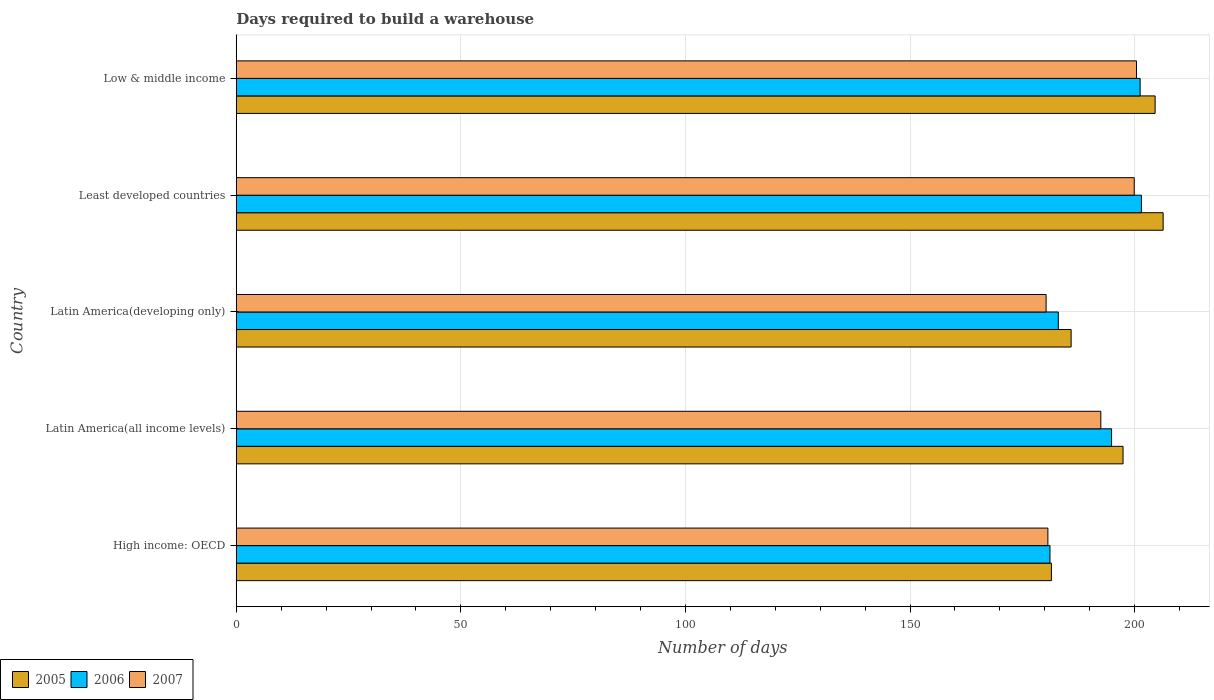How many groups of bars are there?
Offer a very short reply. 5. Are the number of bars per tick equal to the number of legend labels?
Ensure brevity in your answer.  Yes. Are the number of bars on each tick of the Y-axis equal?
Keep it short and to the point. Yes. What is the label of the 2nd group of bars from the top?
Provide a succinct answer. Least developed countries. What is the days required to build a warehouse in in 2007 in Latin America(developing only)?
Your answer should be very brief. 180.29. Across all countries, what is the maximum days required to build a warehouse in in 2007?
Provide a short and direct response. 200.41. Across all countries, what is the minimum days required to build a warehouse in in 2006?
Provide a short and direct response. 181.15. In which country was the days required to build a warehouse in in 2005 maximum?
Provide a short and direct response. Least developed countries. In which country was the days required to build a warehouse in in 2005 minimum?
Give a very brief answer. High income: OECD. What is the total days required to build a warehouse in in 2006 in the graph?
Provide a short and direct response. 961.73. What is the difference between the days required to build a warehouse in in 2006 in Latin America(developing only) and that in Least developed countries?
Provide a short and direct response. -18.5. What is the difference between the days required to build a warehouse in in 2007 in Latin America(developing only) and the days required to build a warehouse in in 2006 in Low & middle income?
Your answer should be very brief. -20.93. What is the average days required to build a warehouse in in 2007 per country?
Your response must be concise. 190.75. What is the difference between the days required to build a warehouse in in 2005 and days required to build a warehouse in in 2006 in Latin America(all income levels)?
Make the answer very short. 2.55. In how many countries, is the days required to build a warehouse in in 2007 greater than 170 days?
Offer a very short reply. 5. What is the ratio of the days required to build a warehouse in in 2005 in Latin America(all income levels) to that in Least developed countries?
Your answer should be compact. 0.96. Is the days required to build a warehouse in in 2006 in Latin America(all income levels) less than that in Latin America(developing only)?
Provide a succinct answer. No. Is the difference between the days required to build a warehouse in in 2005 in Latin America(all income levels) and Latin America(developing only) greater than the difference between the days required to build a warehouse in in 2006 in Latin America(all income levels) and Latin America(developing only)?
Provide a succinct answer. No. What is the difference between the highest and the second highest days required to build a warehouse in in 2006?
Your answer should be compact. 0.28. What is the difference between the highest and the lowest days required to build a warehouse in in 2007?
Ensure brevity in your answer.  20.12. In how many countries, is the days required to build a warehouse in in 2005 greater than the average days required to build a warehouse in in 2005 taken over all countries?
Provide a succinct answer. 3. What does the 3rd bar from the top in Latin America(developing only) represents?
Give a very brief answer. 2005. Is it the case that in every country, the sum of the days required to build a warehouse in in 2006 and days required to build a warehouse in in 2005 is greater than the days required to build a warehouse in in 2007?
Ensure brevity in your answer.  Yes. Are all the bars in the graph horizontal?
Your answer should be compact. Yes. Are the values on the major ticks of X-axis written in scientific E-notation?
Provide a short and direct response. No. What is the title of the graph?
Provide a short and direct response. Days required to build a warehouse. What is the label or title of the X-axis?
Your answer should be compact. Number of days. What is the label or title of the Y-axis?
Your answer should be very brief. Country. What is the Number of days of 2005 in High income: OECD?
Give a very brief answer. 181.47. What is the Number of days in 2006 in High income: OECD?
Ensure brevity in your answer.  181.15. What is the Number of days in 2007 in High income: OECD?
Offer a very short reply. 180.68. What is the Number of days in 2005 in Latin America(all income levels)?
Offer a terse response. 197.41. What is the Number of days of 2006 in Latin America(all income levels)?
Your response must be concise. 194.86. What is the Number of days of 2007 in Latin America(all income levels)?
Make the answer very short. 192.47. What is the Number of days in 2005 in Latin America(developing only)?
Your response must be concise. 185.86. What is the Number of days of 2006 in Latin America(developing only)?
Give a very brief answer. 183. What is the Number of days of 2007 in Latin America(developing only)?
Provide a short and direct response. 180.29. What is the Number of days in 2005 in Least developed countries?
Your response must be concise. 206.34. What is the Number of days of 2006 in Least developed countries?
Offer a terse response. 201.5. What is the Number of days of 2007 in Least developed countries?
Give a very brief answer. 199.9. What is the Number of days of 2005 in Low & middle income?
Your response must be concise. 204.56. What is the Number of days in 2006 in Low & middle income?
Offer a very short reply. 201.22. What is the Number of days of 2007 in Low & middle income?
Provide a succinct answer. 200.41. Across all countries, what is the maximum Number of days in 2005?
Offer a terse response. 206.34. Across all countries, what is the maximum Number of days of 2006?
Your response must be concise. 201.5. Across all countries, what is the maximum Number of days in 2007?
Give a very brief answer. 200.41. Across all countries, what is the minimum Number of days in 2005?
Ensure brevity in your answer.  181.47. Across all countries, what is the minimum Number of days in 2006?
Keep it short and to the point. 181.15. Across all countries, what is the minimum Number of days in 2007?
Provide a short and direct response. 180.29. What is the total Number of days in 2005 in the graph?
Give a very brief answer. 975.63. What is the total Number of days of 2006 in the graph?
Make the answer very short. 961.73. What is the total Number of days in 2007 in the graph?
Give a very brief answer. 953.75. What is the difference between the Number of days of 2005 in High income: OECD and that in Latin America(all income levels)?
Give a very brief answer. -15.95. What is the difference between the Number of days of 2006 in High income: OECD and that in Latin America(all income levels)?
Make the answer very short. -13.71. What is the difference between the Number of days of 2007 in High income: OECD and that in Latin America(all income levels)?
Provide a short and direct response. -11.78. What is the difference between the Number of days in 2005 in High income: OECD and that in Latin America(developing only)?
Offer a very short reply. -4.39. What is the difference between the Number of days in 2006 in High income: OECD and that in Latin America(developing only)?
Make the answer very short. -1.85. What is the difference between the Number of days of 2007 in High income: OECD and that in Latin America(developing only)?
Offer a very short reply. 0.4. What is the difference between the Number of days in 2005 in High income: OECD and that in Least developed countries?
Make the answer very short. -24.88. What is the difference between the Number of days in 2006 in High income: OECD and that in Least developed countries?
Your answer should be compact. -20.35. What is the difference between the Number of days in 2007 in High income: OECD and that in Least developed countries?
Provide a short and direct response. -19.22. What is the difference between the Number of days in 2005 in High income: OECD and that in Low & middle income?
Offer a very short reply. -23.09. What is the difference between the Number of days of 2006 in High income: OECD and that in Low & middle income?
Provide a succinct answer. -20.07. What is the difference between the Number of days of 2007 in High income: OECD and that in Low & middle income?
Offer a terse response. -19.73. What is the difference between the Number of days of 2005 in Latin America(all income levels) and that in Latin America(developing only)?
Provide a short and direct response. 11.56. What is the difference between the Number of days of 2006 in Latin America(all income levels) and that in Latin America(developing only)?
Give a very brief answer. 11.86. What is the difference between the Number of days in 2007 in Latin America(all income levels) and that in Latin America(developing only)?
Give a very brief answer. 12.18. What is the difference between the Number of days in 2005 in Latin America(all income levels) and that in Least developed countries?
Offer a terse response. -8.93. What is the difference between the Number of days of 2006 in Latin America(all income levels) and that in Least developed countries?
Provide a short and direct response. -6.64. What is the difference between the Number of days of 2007 in Latin America(all income levels) and that in Least developed countries?
Provide a succinct answer. -7.44. What is the difference between the Number of days in 2005 in Latin America(all income levels) and that in Low & middle income?
Provide a short and direct response. -7.14. What is the difference between the Number of days of 2006 in Latin America(all income levels) and that in Low & middle income?
Your response must be concise. -6.36. What is the difference between the Number of days of 2007 in Latin America(all income levels) and that in Low & middle income?
Offer a terse response. -7.94. What is the difference between the Number of days of 2005 in Latin America(developing only) and that in Least developed countries?
Offer a very short reply. -20.48. What is the difference between the Number of days in 2006 in Latin America(developing only) and that in Least developed countries?
Ensure brevity in your answer.  -18.5. What is the difference between the Number of days in 2007 in Latin America(developing only) and that in Least developed countries?
Offer a very short reply. -19.62. What is the difference between the Number of days of 2005 in Latin America(developing only) and that in Low & middle income?
Give a very brief answer. -18.7. What is the difference between the Number of days in 2006 in Latin America(developing only) and that in Low & middle income?
Provide a short and direct response. -18.22. What is the difference between the Number of days of 2007 in Latin America(developing only) and that in Low & middle income?
Offer a very short reply. -20.12. What is the difference between the Number of days in 2005 in Least developed countries and that in Low & middle income?
Offer a terse response. 1.78. What is the difference between the Number of days in 2006 in Least developed countries and that in Low & middle income?
Provide a short and direct response. 0.28. What is the difference between the Number of days in 2007 in Least developed countries and that in Low & middle income?
Provide a succinct answer. -0.5. What is the difference between the Number of days in 2005 in High income: OECD and the Number of days in 2006 in Latin America(all income levels)?
Ensure brevity in your answer.  -13.4. What is the difference between the Number of days in 2005 in High income: OECD and the Number of days in 2007 in Latin America(all income levels)?
Ensure brevity in your answer.  -11. What is the difference between the Number of days in 2006 in High income: OECD and the Number of days in 2007 in Latin America(all income levels)?
Provide a succinct answer. -11.32. What is the difference between the Number of days in 2005 in High income: OECD and the Number of days in 2006 in Latin America(developing only)?
Make the answer very short. -1.53. What is the difference between the Number of days of 2005 in High income: OECD and the Number of days of 2007 in Latin America(developing only)?
Your response must be concise. 1.18. What is the difference between the Number of days in 2006 in High income: OECD and the Number of days in 2007 in Latin America(developing only)?
Offer a terse response. 0.86. What is the difference between the Number of days of 2005 in High income: OECD and the Number of days of 2006 in Least developed countries?
Offer a terse response. -20.03. What is the difference between the Number of days in 2005 in High income: OECD and the Number of days in 2007 in Least developed countries?
Provide a succinct answer. -18.44. What is the difference between the Number of days in 2006 in High income: OECD and the Number of days in 2007 in Least developed countries?
Keep it short and to the point. -18.75. What is the difference between the Number of days in 2005 in High income: OECD and the Number of days in 2006 in Low & middle income?
Give a very brief answer. -19.75. What is the difference between the Number of days in 2005 in High income: OECD and the Number of days in 2007 in Low & middle income?
Your response must be concise. -18.94. What is the difference between the Number of days in 2006 in High income: OECD and the Number of days in 2007 in Low & middle income?
Your answer should be very brief. -19.26. What is the difference between the Number of days in 2005 in Latin America(all income levels) and the Number of days in 2006 in Latin America(developing only)?
Your response must be concise. 14.41. What is the difference between the Number of days of 2005 in Latin America(all income levels) and the Number of days of 2007 in Latin America(developing only)?
Make the answer very short. 17.13. What is the difference between the Number of days of 2006 in Latin America(all income levels) and the Number of days of 2007 in Latin America(developing only)?
Your answer should be compact. 14.58. What is the difference between the Number of days in 2005 in Latin America(all income levels) and the Number of days in 2006 in Least developed countries?
Provide a short and direct response. -4.09. What is the difference between the Number of days in 2005 in Latin America(all income levels) and the Number of days in 2007 in Least developed countries?
Keep it short and to the point. -2.49. What is the difference between the Number of days of 2006 in Latin America(all income levels) and the Number of days of 2007 in Least developed countries?
Ensure brevity in your answer.  -5.04. What is the difference between the Number of days of 2005 in Latin America(all income levels) and the Number of days of 2006 in Low & middle income?
Offer a very short reply. -3.81. What is the difference between the Number of days in 2005 in Latin America(all income levels) and the Number of days in 2007 in Low & middle income?
Provide a short and direct response. -3. What is the difference between the Number of days in 2006 in Latin America(all income levels) and the Number of days in 2007 in Low & middle income?
Keep it short and to the point. -5.55. What is the difference between the Number of days of 2005 in Latin America(developing only) and the Number of days of 2006 in Least developed countries?
Keep it short and to the point. -15.64. What is the difference between the Number of days in 2005 in Latin America(developing only) and the Number of days in 2007 in Least developed countries?
Your response must be concise. -14.05. What is the difference between the Number of days in 2006 in Latin America(developing only) and the Number of days in 2007 in Least developed countries?
Offer a very short reply. -16.9. What is the difference between the Number of days in 2005 in Latin America(developing only) and the Number of days in 2006 in Low & middle income?
Your response must be concise. -15.36. What is the difference between the Number of days of 2005 in Latin America(developing only) and the Number of days of 2007 in Low & middle income?
Ensure brevity in your answer.  -14.55. What is the difference between the Number of days of 2006 in Latin America(developing only) and the Number of days of 2007 in Low & middle income?
Provide a short and direct response. -17.41. What is the difference between the Number of days of 2005 in Least developed countries and the Number of days of 2006 in Low & middle income?
Make the answer very short. 5.12. What is the difference between the Number of days in 2005 in Least developed countries and the Number of days in 2007 in Low & middle income?
Ensure brevity in your answer.  5.93. What is the difference between the Number of days of 2006 in Least developed countries and the Number of days of 2007 in Low & middle income?
Your answer should be very brief. 1.09. What is the average Number of days of 2005 per country?
Ensure brevity in your answer.  195.13. What is the average Number of days of 2006 per country?
Your answer should be very brief. 192.35. What is the average Number of days of 2007 per country?
Ensure brevity in your answer.  190.75. What is the difference between the Number of days in 2005 and Number of days in 2006 in High income: OECD?
Your answer should be very brief. 0.32. What is the difference between the Number of days of 2005 and Number of days of 2007 in High income: OECD?
Ensure brevity in your answer.  0.78. What is the difference between the Number of days in 2006 and Number of days in 2007 in High income: OECD?
Your response must be concise. 0.47. What is the difference between the Number of days in 2005 and Number of days in 2006 in Latin America(all income levels)?
Your answer should be very brief. 2.55. What is the difference between the Number of days of 2005 and Number of days of 2007 in Latin America(all income levels)?
Offer a very short reply. 4.95. What is the difference between the Number of days of 2006 and Number of days of 2007 in Latin America(all income levels)?
Your answer should be very brief. 2.4. What is the difference between the Number of days of 2005 and Number of days of 2006 in Latin America(developing only)?
Give a very brief answer. 2.86. What is the difference between the Number of days in 2005 and Number of days in 2007 in Latin America(developing only)?
Keep it short and to the point. 5.57. What is the difference between the Number of days in 2006 and Number of days in 2007 in Latin America(developing only)?
Give a very brief answer. 2.71. What is the difference between the Number of days in 2005 and Number of days in 2006 in Least developed countries?
Provide a short and direct response. 4.84. What is the difference between the Number of days in 2005 and Number of days in 2007 in Least developed countries?
Offer a very short reply. 6.44. What is the difference between the Number of days in 2006 and Number of days in 2007 in Least developed countries?
Provide a short and direct response. 1.6. What is the difference between the Number of days of 2005 and Number of days of 2006 in Low & middle income?
Your answer should be compact. 3.34. What is the difference between the Number of days of 2005 and Number of days of 2007 in Low & middle income?
Your response must be concise. 4.15. What is the difference between the Number of days in 2006 and Number of days in 2007 in Low & middle income?
Offer a very short reply. 0.81. What is the ratio of the Number of days in 2005 in High income: OECD to that in Latin America(all income levels)?
Make the answer very short. 0.92. What is the ratio of the Number of days in 2006 in High income: OECD to that in Latin America(all income levels)?
Offer a terse response. 0.93. What is the ratio of the Number of days of 2007 in High income: OECD to that in Latin America(all income levels)?
Offer a terse response. 0.94. What is the ratio of the Number of days in 2005 in High income: OECD to that in Latin America(developing only)?
Your answer should be very brief. 0.98. What is the ratio of the Number of days in 2007 in High income: OECD to that in Latin America(developing only)?
Offer a terse response. 1. What is the ratio of the Number of days in 2005 in High income: OECD to that in Least developed countries?
Provide a succinct answer. 0.88. What is the ratio of the Number of days of 2006 in High income: OECD to that in Least developed countries?
Ensure brevity in your answer.  0.9. What is the ratio of the Number of days in 2007 in High income: OECD to that in Least developed countries?
Provide a succinct answer. 0.9. What is the ratio of the Number of days of 2005 in High income: OECD to that in Low & middle income?
Provide a succinct answer. 0.89. What is the ratio of the Number of days in 2006 in High income: OECD to that in Low & middle income?
Give a very brief answer. 0.9. What is the ratio of the Number of days of 2007 in High income: OECD to that in Low & middle income?
Provide a short and direct response. 0.9. What is the ratio of the Number of days in 2005 in Latin America(all income levels) to that in Latin America(developing only)?
Provide a succinct answer. 1.06. What is the ratio of the Number of days in 2006 in Latin America(all income levels) to that in Latin America(developing only)?
Give a very brief answer. 1.06. What is the ratio of the Number of days of 2007 in Latin America(all income levels) to that in Latin America(developing only)?
Your response must be concise. 1.07. What is the ratio of the Number of days in 2005 in Latin America(all income levels) to that in Least developed countries?
Ensure brevity in your answer.  0.96. What is the ratio of the Number of days of 2006 in Latin America(all income levels) to that in Least developed countries?
Your answer should be compact. 0.97. What is the ratio of the Number of days of 2007 in Latin America(all income levels) to that in Least developed countries?
Keep it short and to the point. 0.96. What is the ratio of the Number of days in 2005 in Latin America(all income levels) to that in Low & middle income?
Your answer should be compact. 0.97. What is the ratio of the Number of days of 2006 in Latin America(all income levels) to that in Low & middle income?
Keep it short and to the point. 0.97. What is the ratio of the Number of days of 2007 in Latin America(all income levels) to that in Low & middle income?
Your answer should be very brief. 0.96. What is the ratio of the Number of days of 2005 in Latin America(developing only) to that in Least developed countries?
Provide a short and direct response. 0.9. What is the ratio of the Number of days in 2006 in Latin America(developing only) to that in Least developed countries?
Make the answer very short. 0.91. What is the ratio of the Number of days in 2007 in Latin America(developing only) to that in Least developed countries?
Provide a short and direct response. 0.9. What is the ratio of the Number of days in 2005 in Latin America(developing only) to that in Low & middle income?
Provide a short and direct response. 0.91. What is the ratio of the Number of days of 2006 in Latin America(developing only) to that in Low & middle income?
Offer a terse response. 0.91. What is the ratio of the Number of days in 2007 in Latin America(developing only) to that in Low & middle income?
Ensure brevity in your answer.  0.9. What is the ratio of the Number of days in 2005 in Least developed countries to that in Low & middle income?
Offer a very short reply. 1.01. What is the ratio of the Number of days of 2006 in Least developed countries to that in Low & middle income?
Give a very brief answer. 1. What is the ratio of the Number of days in 2007 in Least developed countries to that in Low & middle income?
Offer a terse response. 1. What is the difference between the highest and the second highest Number of days of 2005?
Offer a very short reply. 1.78. What is the difference between the highest and the second highest Number of days in 2006?
Keep it short and to the point. 0.28. What is the difference between the highest and the second highest Number of days in 2007?
Provide a short and direct response. 0.5. What is the difference between the highest and the lowest Number of days in 2005?
Offer a very short reply. 24.88. What is the difference between the highest and the lowest Number of days in 2006?
Make the answer very short. 20.35. What is the difference between the highest and the lowest Number of days in 2007?
Provide a succinct answer. 20.12. 